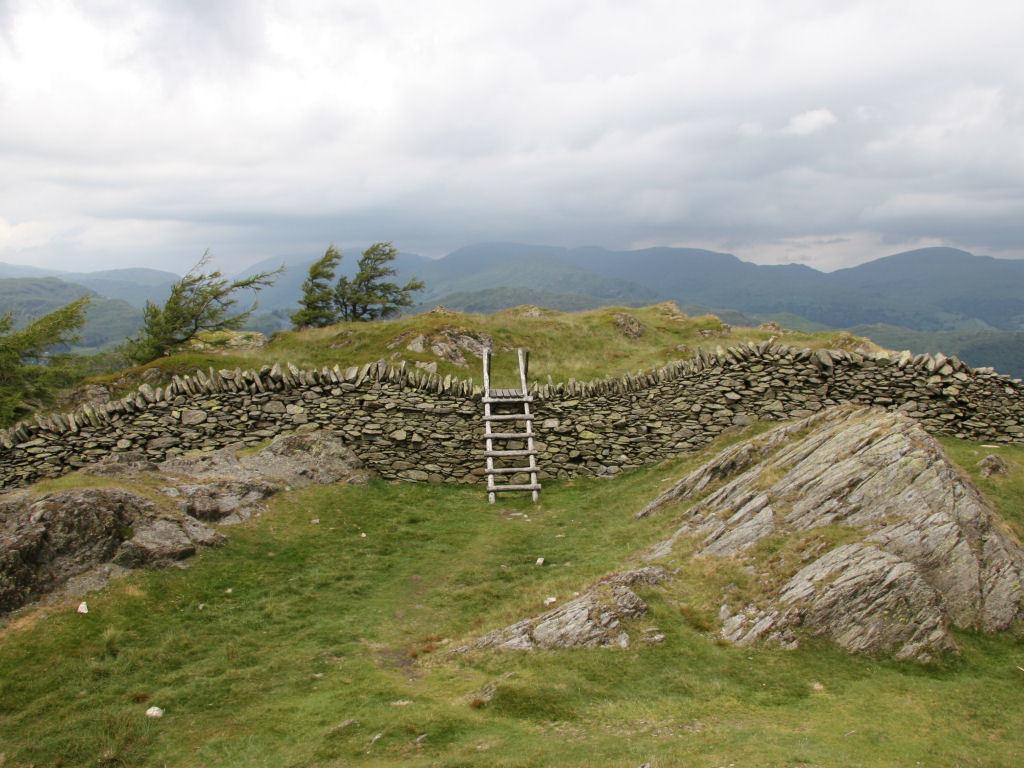How would you summarize this image in a sentence or two? This image is taken outdoors. At the top of the image there is a sky with clouds. At the bottom of the image there is a ground with grass and a rock on it. In the background there are a few hills. In the middle of the image there are many stones and there is a ladder. There are a few trees. 